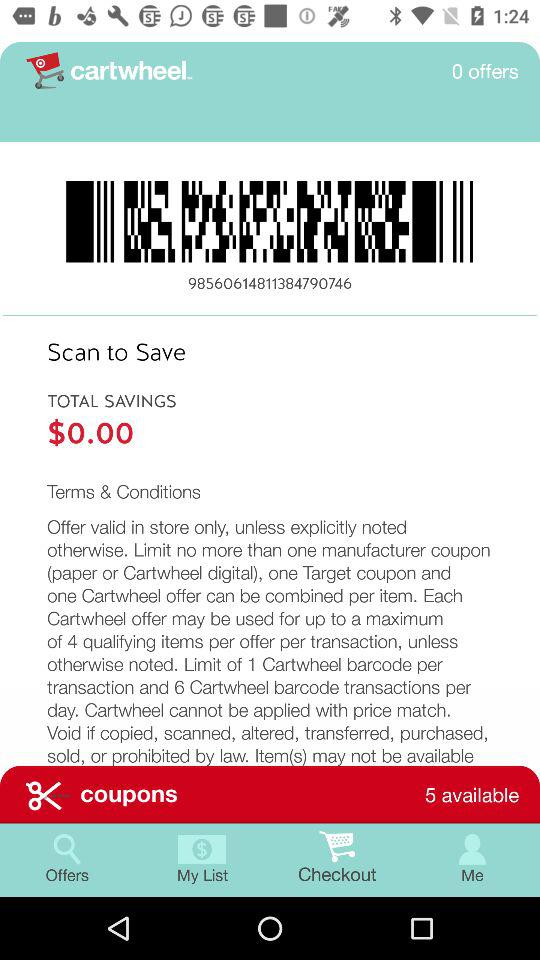What is the name of the application? The name of the application is "cartwheel". 